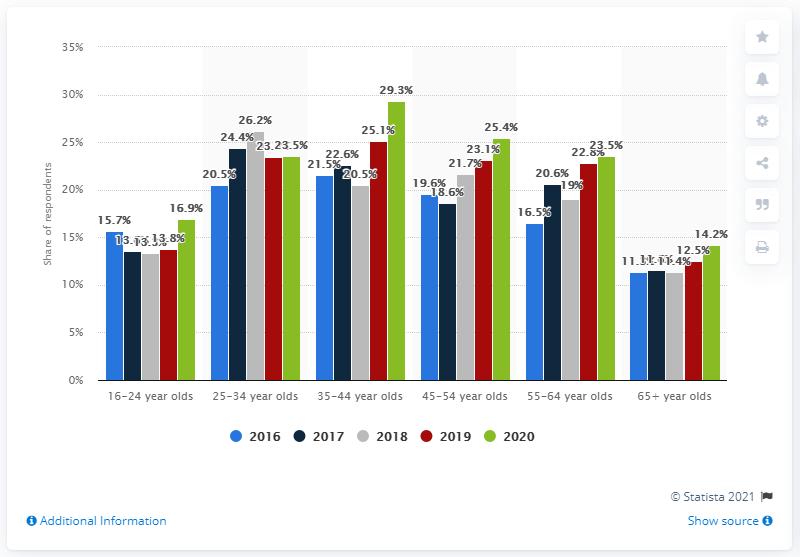Give some essential details in this illustration. In the past four weeks, 29.3% of people between the ages of 35 and 44 reported having participated in some form of online gambling. 